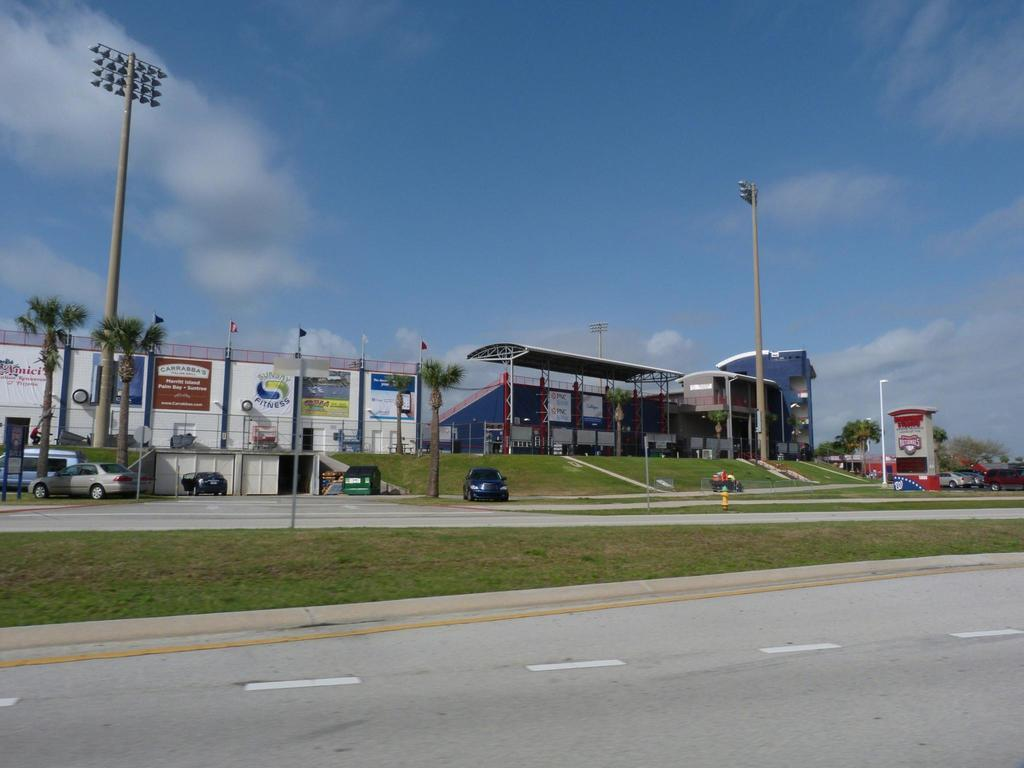What types of structures can be seen in the image? There are houses and buildings in the image. What else is present in the image besides structures? There are vehicles, poles, trees, and a road with lines and grass at the bottom of the image. What can be seen in the background of the image? The sky is visible in the background of the image. Where can the oranges be found in the image? There are no oranges present in the image. What type of water body can be seen in the image? There is no water body, such as an ocean, present in the image. 